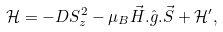Convert formula to latex. <formula><loc_0><loc_0><loc_500><loc_500>\mathcal { H } = - D S _ { z } ^ { 2 } - \mu _ { B } \vec { H } . \hat { g } . \vec { S } + \mathcal { H } ^ { \prime } ,</formula> 